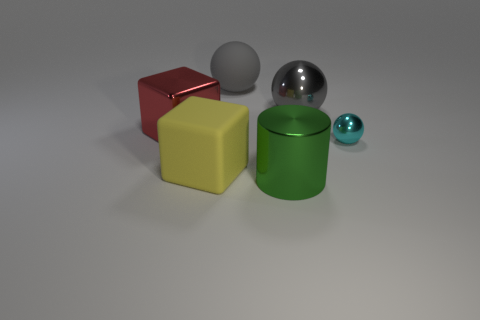There is a large matte thing behind the large red shiny thing; does it have the same color as the large metallic ball?
Give a very brief answer. Yes. What number of things are rubber objects or big shiny objects that are to the right of the yellow object?
Offer a very short reply. 4. There is a large gray object left of the large shiny cylinder; is its shape the same as the gray object that is to the right of the matte sphere?
Your answer should be very brief. Yes. Is there any other thing that has the same color as the big rubber sphere?
Offer a terse response. Yes. There is a big green object that is the same material as the big red thing; what shape is it?
Offer a very short reply. Cylinder. What is the material of the object that is to the right of the metal block and on the left side of the big gray rubber sphere?
Keep it short and to the point. Rubber. Are there any other things that have the same size as the cyan object?
Give a very brief answer. No. Do the large rubber sphere and the big metal sphere have the same color?
Your answer should be very brief. Yes. The large object that is the same color as the large metal sphere is what shape?
Your answer should be compact. Sphere. How many red shiny objects have the same shape as the big yellow matte object?
Provide a succinct answer. 1. 